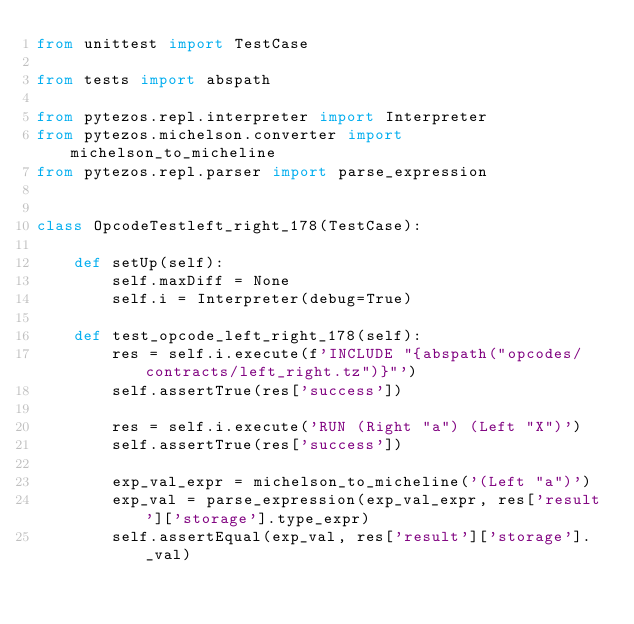<code> <loc_0><loc_0><loc_500><loc_500><_Python_>from unittest import TestCase

from tests import abspath

from pytezos.repl.interpreter import Interpreter
from pytezos.michelson.converter import michelson_to_micheline
from pytezos.repl.parser import parse_expression


class OpcodeTestleft_right_178(TestCase):

    def setUp(self):
        self.maxDiff = None
        self.i = Interpreter(debug=True)
        
    def test_opcode_left_right_178(self):
        res = self.i.execute(f'INCLUDE "{abspath("opcodes/contracts/left_right.tz")}"')
        self.assertTrue(res['success'])
        
        res = self.i.execute('RUN (Right "a") (Left "X")')
        self.assertTrue(res['success'])
        
        exp_val_expr = michelson_to_micheline('(Left "a")')
        exp_val = parse_expression(exp_val_expr, res['result']['storage'].type_expr)
        self.assertEqual(exp_val, res['result']['storage']._val)
</code> 